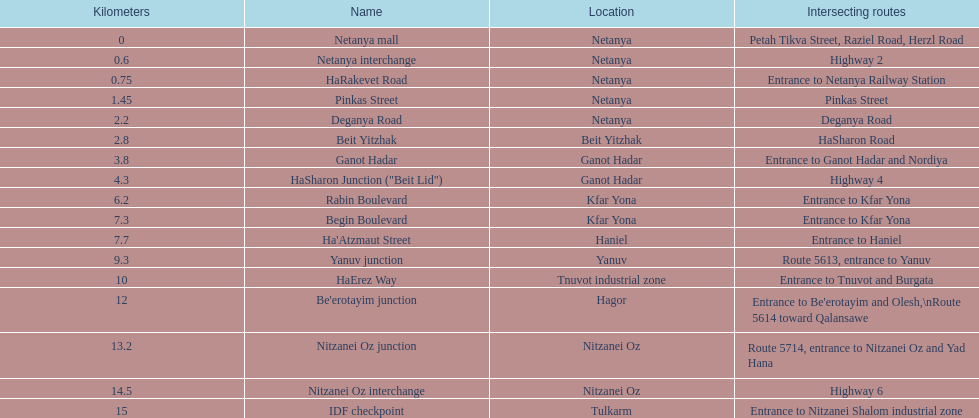Parse the full table. {'header': ['Kilometers', 'Name', 'Location', 'Intersecting routes'], 'rows': [['0', 'Netanya mall', 'Netanya', 'Petah Tikva Street, Raziel Road, Herzl Road'], ['0.6', 'Netanya interchange', 'Netanya', 'Highway 2'], ['0.75', 'HaRakevet Road', 'Netanya', 'Entrance to Netanya Railway Station'], ['1.45', 'Pinkas Street', 'Netanya', 'Pinkas Street'], ['2.2', 'Deganya Road', 'Netanya', 'Deganya Road'], ['2.8', 'Beit Yitzhak', 'Beit Yitzhak', 'HaSharon Road'], ['3.8', 'Ganot Hadar', 'Ganot Hadar', 'Entrance to Ganot Hadar and Nordiya'], ['4.3', 'HaSharon Junction ("Beit Lid")', 'Ganot Hadar', 'Highway 4'], ['6.2', 'Rabin Boulevard', 'Kfar Yona', 'Entrance to Kfar Yona'], ['7.3', 'Begin Boulevard', 'Kfar Yona', 'Entrance to Kfar Yona'], ['7.7', "Ha'Atzmaut Street", 'Haniel', 'Entrance to Haniel'], ['9.3', 'Yanuv junction', 'Yanuv', 'Route 5613, entrance to Yanuv'], ['10', 'HaErez Way', 'Tnuvot industrial zone', 'Entrance to Tnuvot and Burgata'], ['12', "Be'erotayim junction", 'Hagor', "Entrance to Be'erotayim and Olesh,\\nRoute 5614 toward Qalansawe"], ['13.2', 'Nitzanei Oz junction', 'Nitzanei Oz', 'Route 5714, entrance to Nitzanei Oz and Yad Hana'], ['14.5', 'Nitzanei Oz interchange', 'Nitzanei Oz', 'Highway 6'], ['15', 'IDF checkpoint', 'Tulkarm', 'Entrance to Nitzanei Shalom industrial zone']]} How many locations in netanya are there? 5. 